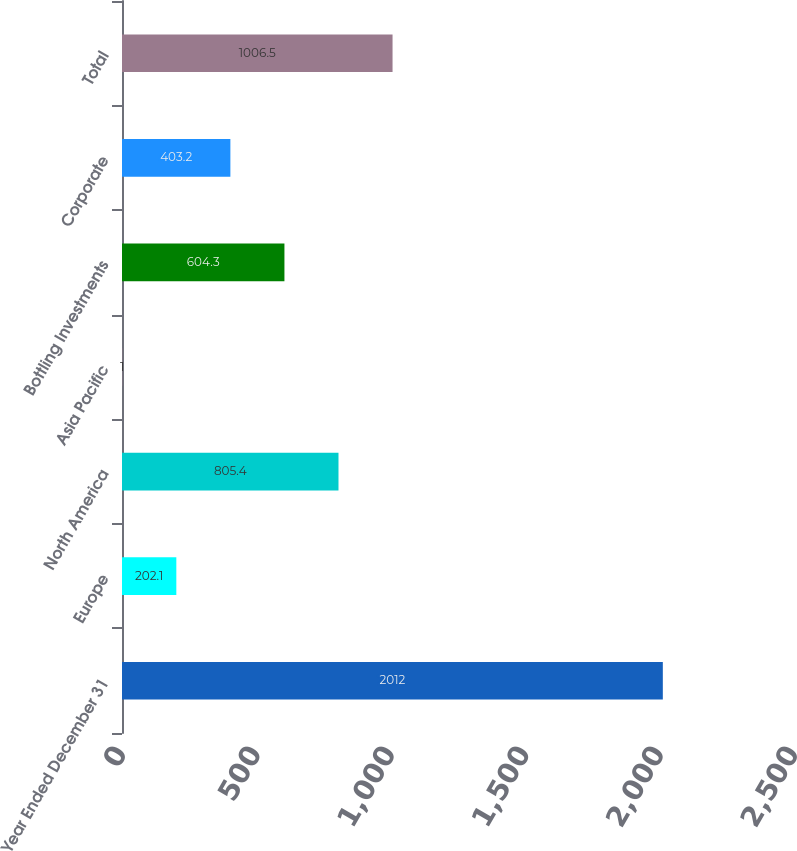<chart> <loc_0><loc_0><loc_500><loc_500><bar_chart><fcel>Year Ended December 31<fcel>Europe<fcel>North America<fcel>Asia Pacific<fcel>Bottling Investments<fcel>Corporate<fcel>Total<nl><fcel>2012<fcel>202.1<fcel>805.4<fcel>1<fcel>604.3<fcel>403.2<fcel>1006.5<nl></chart> 